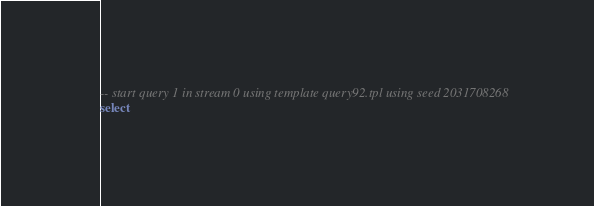<code> <loc_0><loc_0><loc_500><loc_500><_SQL_>-- start query 1 in stream 0 using template query92.tpl using seed 2031708268
select  </code> 